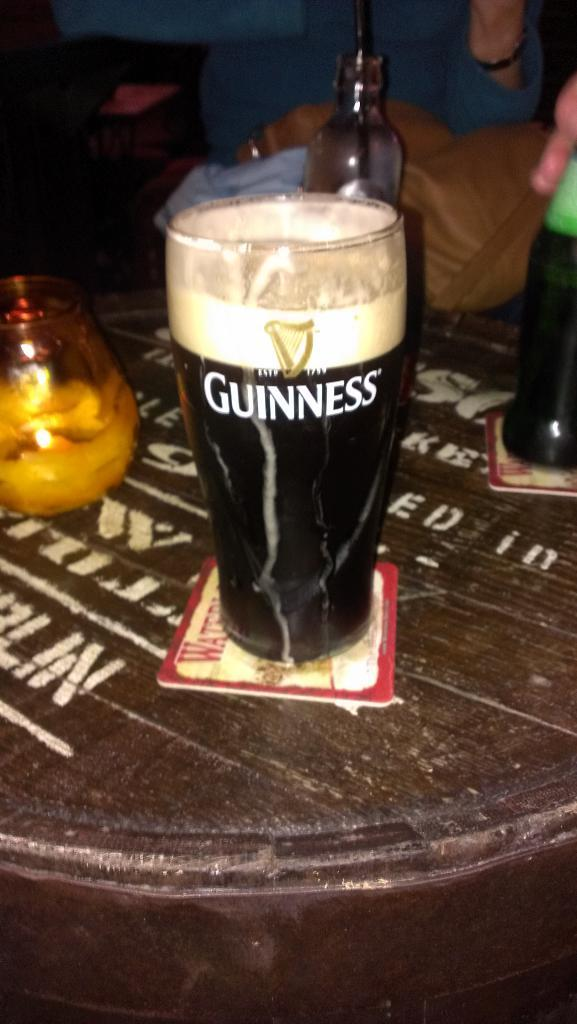<image>
Provide a brief description of the given image. A pint glass full of Guinness sits on a coaster. 